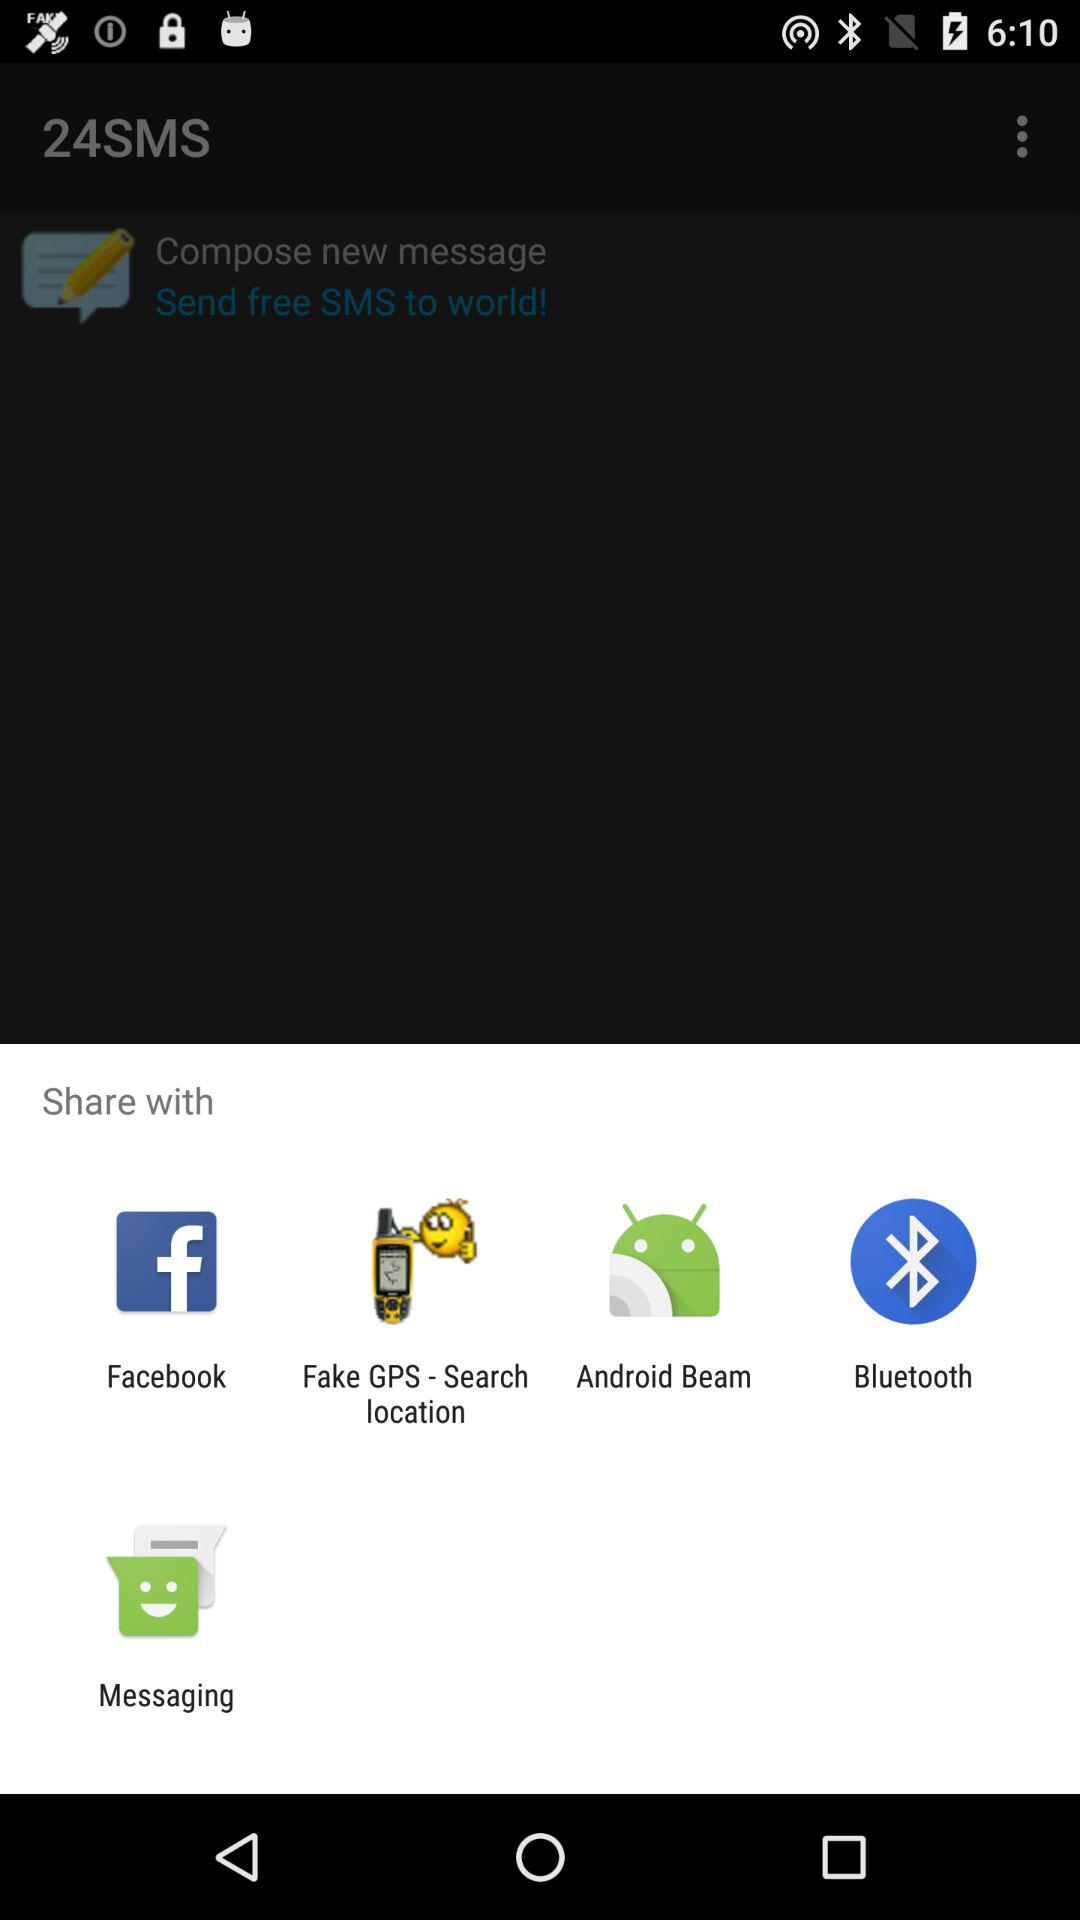Which app can we share the content with? You can share the content with "Facebook", "Fake GPS - Search location", "Android Beam", "Bluetooth" and "Messaging". 